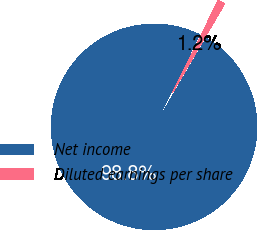Convert chart. <chart><loc_0><loc_0><loc_500><loc_500><pie_chart><fcel>Net income<fcel>Diluted earnings per share<nl><fcel>98.84%<fcel>1.16%<nl></chart> 